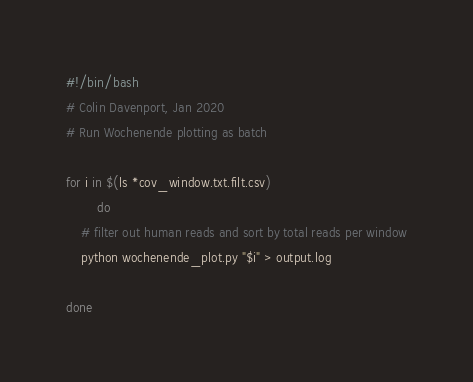Convert code to text. <code><loc_0><loc_0><loc_500><loc_500><_Bash_>#!/bin/bash
# Colin Davenport, Jan 2020
# Run Wochenende plotting as batch

for i in $(ls *cov_window.txt.filt.csv)
        do
	# filter out human reads and sort by total reads per window
	python wochenende_plot.py "$i" > output.log

done

</code> 